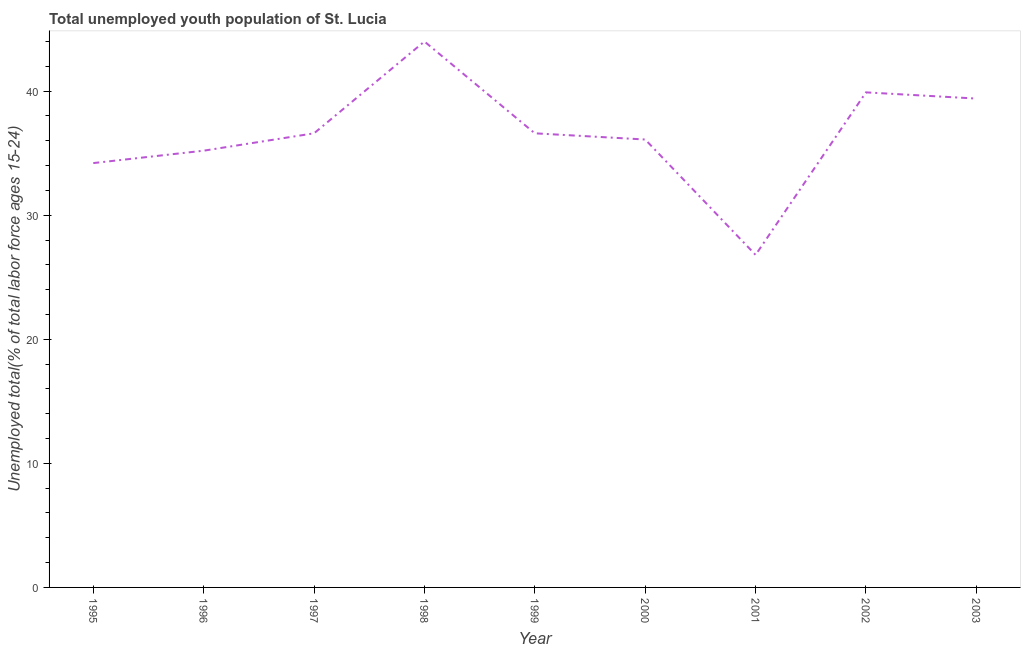What is the unemployed youth in 2003?
Your answer should be compact. 39.4. Across all years, what is the minimum unemployed youth?
Ensure brevity in your answer.  26.8. In which year was the unemployed youth maximum?
Offer a very short reply. 1998. What is the sum of the unemployed youth?
Offer a terse response. 328.8. What is the difference between the unemployed youth in 1997 and 2002?
Your answer should be compact. -3.3. What is the average unemployed youth per year?
Offer a terse response. 36.53. What is the median unemployed youth?
Ensure brevity in your answer.  36.6. What is the ratio of the unemployed youth in 1999 to that in 2003?
Give a very brief answer. 0.93. Is the unemployed youth in 1998 less than that in 2001?
Offer a terse response. No. Is the difference between the unemployed youth in 1995 and 1996 greater than the difference between any two years?
Give a very brief answer. No. What is the difference between the highest and the second highest unemployed youth?
Provide a succinct answer. 4.1. Is the sum of the unemployed youth in 1998 and 2001 greater than the maximum unemployed youth across all years?
Ensure brevity in your answer.  Yes. What is the difference between the highest and the lowest unemployed youth?
Your answer should be very brief. 17.2. How many lines are there?
Your answer should be compact. 1. What is the difference between two consecutive major ticks on the Y-axis?
Your response must be concise. 10. Does the graph contain any zero values?
Make the answer very short. No. What is the title of the graph?
Your response must be concise. Total unemployed youth population of St. Lucia. What is the label or title of the Y-axis?
Make the answer very short. Unemployed total(% of total labor force ages 15-24). What is the Unemployed total(% of total labor force ages 15-24) of 1995?
Ensure brevity in your answer.  34.2. What is the Unemployed total(% of total labor force ages 15-24) in 1996?
Offer a very short reply. 35.2. What is the Unemployed total(% of total labor force ages 15-24) of 1997?
Give a very brief answer. 36.6. What is the Unemployed total(% of total labor force ages 15-24) in 1999?
Make the answer very short. 36.6. What is the Unemployed total(% of total labor force ages 15-24) of 2000?
Keep it short and to the point. 36.1. What is the Unemployed total(% of total labor force ages 15-24) of 2001?
Offer a terse response. 26.8. What is the Unemployed total(% of total labor force ages 15-24) in 2002?
Your answer should be compact. 39.9. What is the Unemployed total(% of total labor force ages 15-24) in 2003?
Keep it short and to the point. 39.4. What is the difference between the Unemployed total(% of total labor force ages 15-24) in 1995 and 1998?
Your response must be concise. -9.8. What is the difference between the Unemployed total(% of total labor force ages 15-24) in 1995 and 1999?
Make the answer very short. -2.4. What is the difference between the Unemployed total(% of total labor force ages 15-24) in 1995 and 2002?
Provide a succinct answer. -5.7. What is the difference between the Unemployed total(% of total labor force ages 15-24) in 1995 and 2003?
Offer a very short reply. -5.2. What is the difference between the Unemployed total(% of total labor force ages 15-24) in 1996 and 1997?
Your response must be concise. -1.4. What is the difference between the Unemployed total(% of total labor force ages 15-24) in 1996 and 2002?
Keep it short and to the point. -4.7. What is the difference between the Unemployed total(% of total labor force ages 15-24) in 1997 and 1998?
Your answer should be very brief. -7.4. What is the difference between the Unemployed total(% of total labor force ages 15-24) in 1997 and 2002?
Your response must be concise. -3.3. What is the difference between the Unemployed total(% of total labor force ages 15-24) in 1997 and 2003?
Provide a succinct answer. -2.8. What is the difference between the Unemployed total(% of total labor force ages 15-24) in 1998 and 1999?
Offer a very short reply. 7.4. What is the difference between the Unemployed total(% of total labor force ages 15-24) in 1998 and 2000?
Give a very brief answer. 7.9. What is the difference between the Unemployed total(% of total labor force ages 15-24) in 1998 and 2002?
Offer a terse response. 4.1. What is the difference between the Unemployed total(% of total labor force ages 15-24) in 1999 and 2002?
Your response must be concise. -3.3. What is the difference between the Unemployed total(% of total labor force ages 15-24) in 2000 and 2002?
Ensure brevity in your answer.  -3.8. What is the difference between the Unemployed total(% of total labor force ages 15-24) in 2000 and 2003?
Make the answer very short. -3.3. What is the ratio of the Unemployed total(% of total labor force ages 15-24) in 1995 to that in 1996?
Your answer should be very brief. 0.97. What is the ratio of the Unemployed total(% of total labor force ages 15-24) in 1995 to that in 1997?
Provide a succinct answer. 0.93. What is the ratio of the Unemployed total(% of total labor force ages 15-24) in 1995 to that in 1998?
Offer a very short reply. 0.78. What is the ratio of the Unemployed total(% of total labor force ages 15-24) in 1995 to that in 1999?
Offer a terse response. 0.93. What is the ratio of the Unemployed total(% of total labor force ages 15-24) in 1995 to that in 2000?
Your answer should be compact. 0.95. What is the ratio of the Unemployed total(% of total labor force ages 15-24) in 1995 to that in 2001?
Your answer should be compact. 1.28. What is the ratio of the Unemployed total(% of total labor force ages 15-24) in 1995 to that in 2002?
Offer a terse response. 0.86. What is the ratio of the Unemployed total(% of total labor force ages 15-24) in 1995 to that in 2003?
Offer a terse response. 0.87. What is the ratio of the Unemployed total(% of total labor force ages 15-24) in 1996 to that in 1998?
Your answer should be compact. 0.8. What is the ratio of the Unemployed total(% of total labor force ages 15-24) in 1996 to that in 2001?
Your answer should be very brief. 1.31. What is the ratio of the Unemployed total(% of total labor force ages 15-24) in 1996 to that in 2002?
Ensure brevity in your answer.  0.88. What is the ratio of the Unemployed total(% of total labor force ages 15-24) in 1996 to that in 2003?
Provide a succinct answer. 0.89. What is the ratio of the Unemployed total(% of total labor force ages 15-24) in 1997 to that in 1998?
Offer a very short reply. 0.83. What is the ratio of the Unemployed total(% of total labor force ages 15-24) in 1997 to that in 1999?
Provide a succinct answer. 1. What is the ratio of the Unemployed total(% of total labor force ages 15-24) in 1997 to that in 2001?
Make the answer very short. 1.37. What is the ratio of the Unemployed total(% of total labor force ages 15-24) in 1997 to that in 2002?
Your answer should be very brief. 0.92. What is the ratio of the Unemployed total(% of total labor force ages 15-24) in 1997 to that in 2003?
Provide a short and direct response. 0.93. What is the ratio of the Unemployed total(% of total labor force ages 15-24) in 1998 to that in 1999?
Offer a very short reply. 1.2. What is the ratio of the Unemployed total(% of total labor force ages 15-24) in 1998 to that in 2000?
Provide a succinct answer. 1.22. What is the ratio of the Unemployed total(% of total labor force ages 15-24) in 1998 to that in 2001?
Your answer should be very brief. 1.64. What is the ratio of the Unemployed total(% of total labor force ages 15-24) in 1998 to that in 2002?
Provide a succinct answer. 1.1. What is the ratio of the Unemployed total(% of total labor force ages 15-24) in 1998 to that in 2003?
Your answer should be compact. 1.12. What is the ratio of the Unemployed total(% of total labor force ages 15-24) in 1999 to that in 2000?
Make the answer very short. 1.01. What is the ratio of the Unemployed total(% of total labor force ages 15-24) in 1999 to that in 2001?
Your answer should be compact. 1.37. What is the ratio of the Unemployed total(% of total labor force ages 15-24) in 1999 to that in 2002?
Your answer should be compact. 0.92. What is the ratio of the Unemployed total(% of total labor force ages 15-24) in 1999 to that in 2003?
Make the answer very short. 0.93. What is the ratio of the Unemployed total(% of total labor force ages 15-24) in 2000 to that in 2001?
Give a very brief answer. 1.35. What is the ratio of the Unemployed total(% of total labor force ages 15-24) in 2000 to that in 2002?
Give a very brief answer. 0.91. What is the ratio of the Unemployed total(% of total labor force ages 15-24) in 2000 to that in 2003?
Offer a very short reply. 0.92. What is the ratio of the Unemployed total(% of total labor force ages 15-24) in 2001 to that in 2002?
Give a very brief answer. 0.67. What is the ratio of the Unemployed total(% of total labor force ages 15-24) in 2001 to that in 2003?
Your answer should be compact. 0.68. What is the ratio of the Unemployed total(% of total labor force ages 15-24) in 2002 to that in 2003?
Provide a succinct answer. 1.01. 